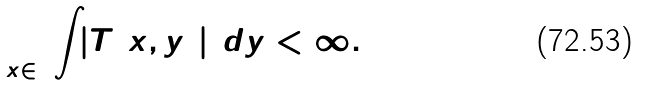<formula> <loc_0><loc_0><loc_500><loc_500>\sup _ { { x } \in \L } \int _ { \L } | T ( { x } , { y } ) | ^ { 2 } d { y } < \infty .</formula> 